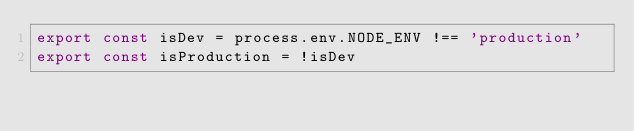Convert code to text. <code><loc_0><loc_0><loc_500><loc_500><_JavaScript_>export const isDev = process.env.NODE_ENV !== 'production'
export const isProduction = !isDev
</code> 